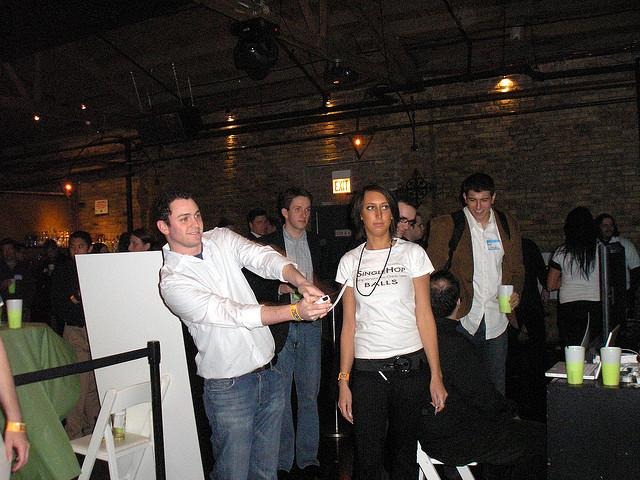Why is the man swinging his arm? playing game 